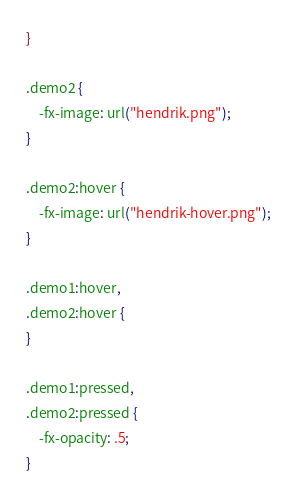<code> <loc_0><loc_0><loc_500><loc_500><_CSS_>}

.demo2 {
    -fx-image: url("hendrik.png");
}

.demo2:hover {
    -fx-image: url("hendrik-hover.png");
}

.demo1:hover,
.demo2:hover {
}

.demo1:pressed,
.demo2:pressed {
    -fx-opacity: .5;
}</code> 